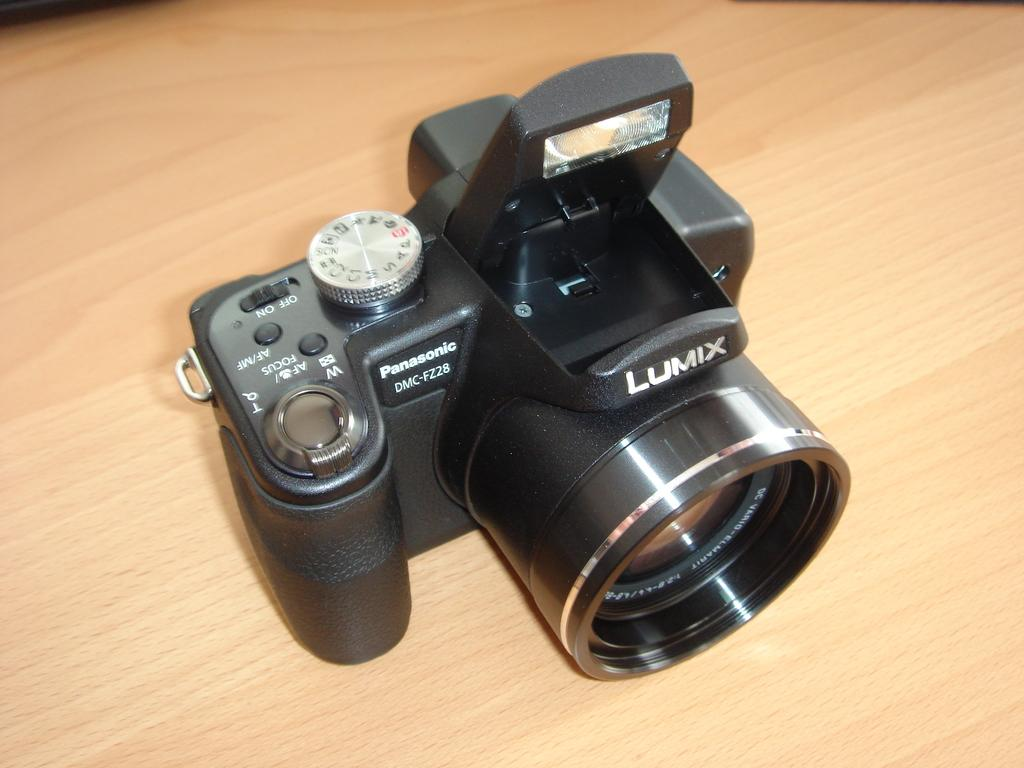What is the main object in the center of the image? There is a table in the center of the image. What is placed on the table? There is a camera on the table. What is the color of the camera? The camera is black in color. What type of boundary can be seen in the image? There is no boundary visible in the image; it only features a table and a black camera. How many houses are present in the image? There are no houses present in the image; it only features a table and a black camera. 